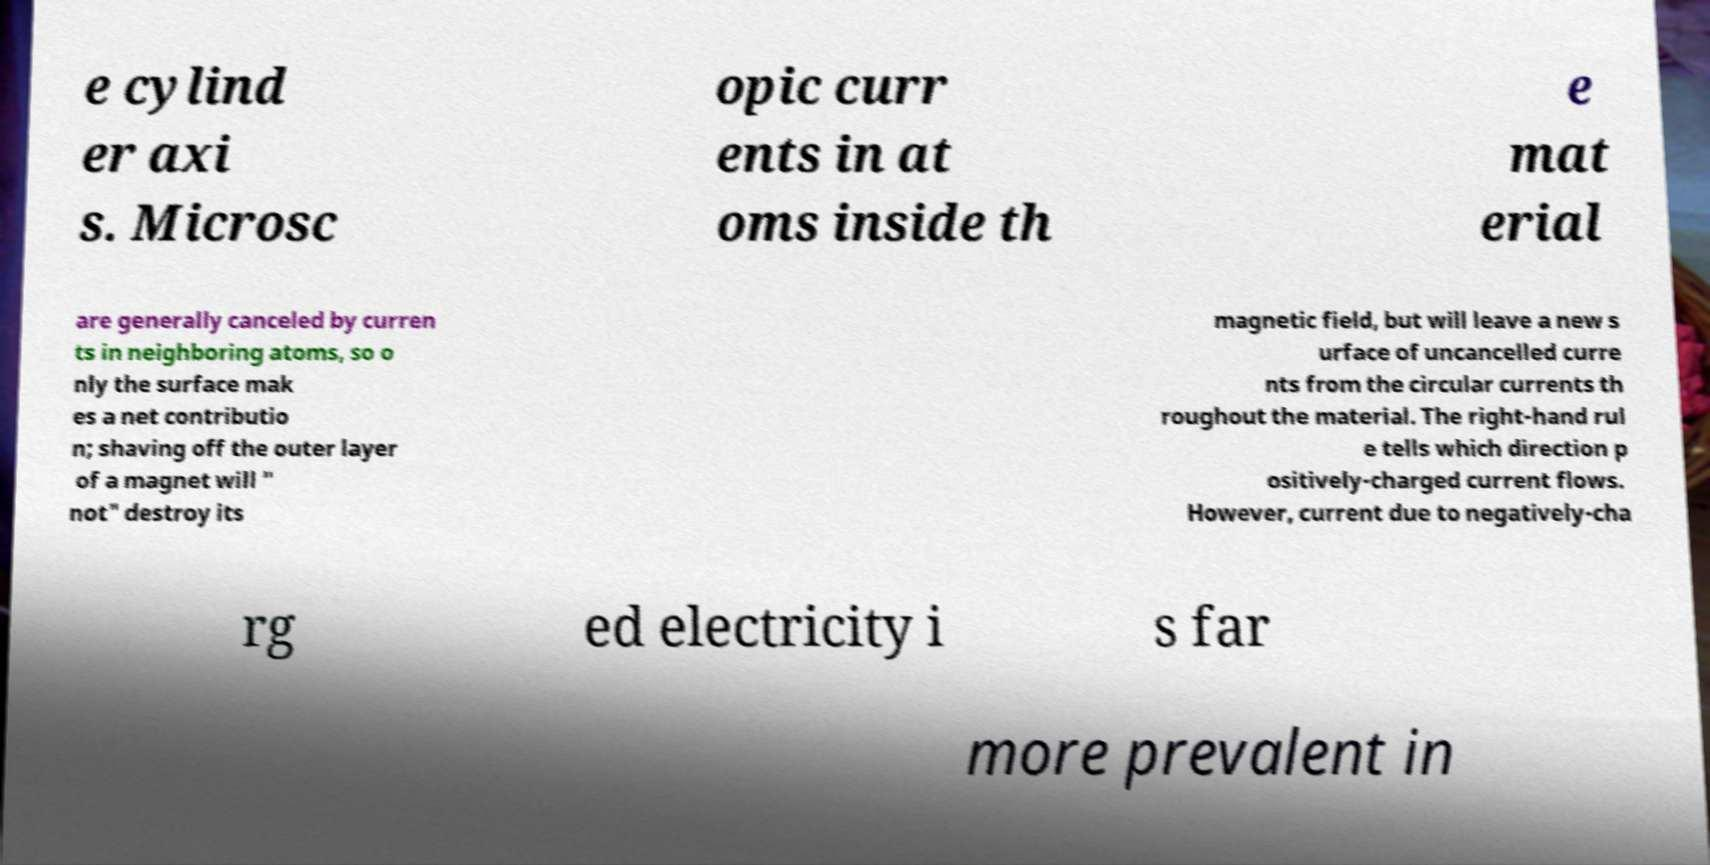Could you assist in decoding the text presented in this image and type it out clearly? e cylind er axi s. Microsc opic curr ents in at oms inside th e mat erial are generally canceled by curren ts in neighboring atoms, so o nly the surface mak es a net contributio n; shaving off the outer layer of a magnet will " not" destroy its magnetic field, but will leave a new s urface of uncancelled curre nts from the circular currents th roughout the material. The right-hand rul e tells which direction p ositively-charged current flows. However, current due to negatively-cha rg ed electricity i s far more prevalent in 